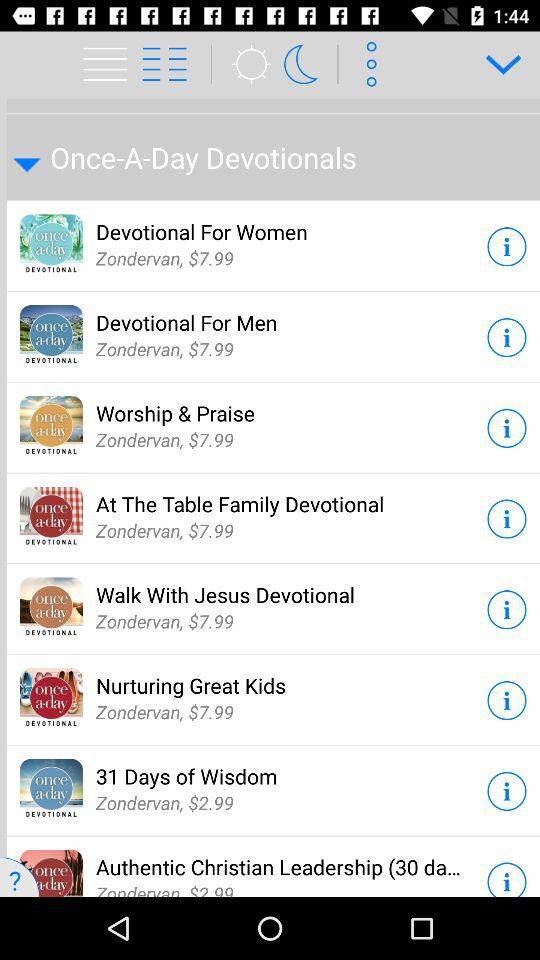What is the duration of "Worship & Praise"?
When the provided information is insufficient, respond with <no answer>. <no answer> 